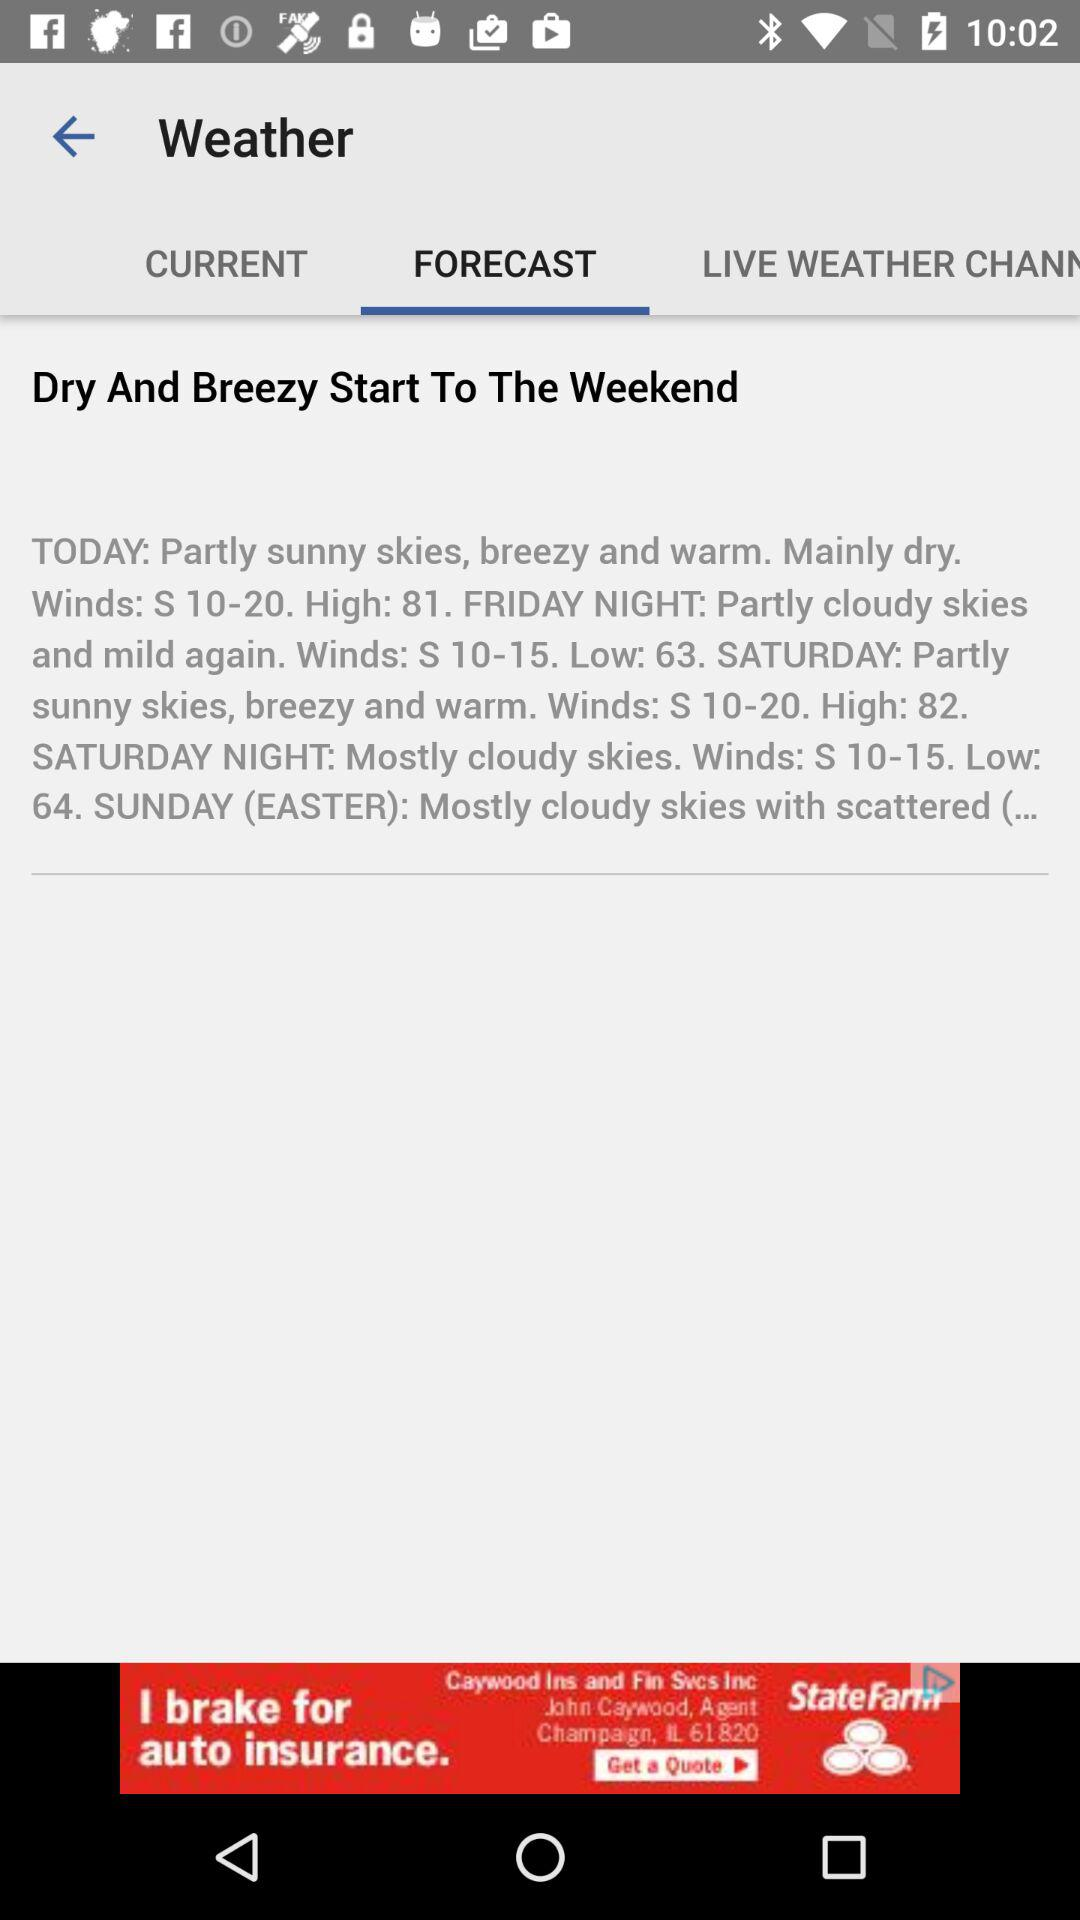How is the weather on Sunday? The weather on Sunday is "Mostly cloudy skies with scattered (...". 